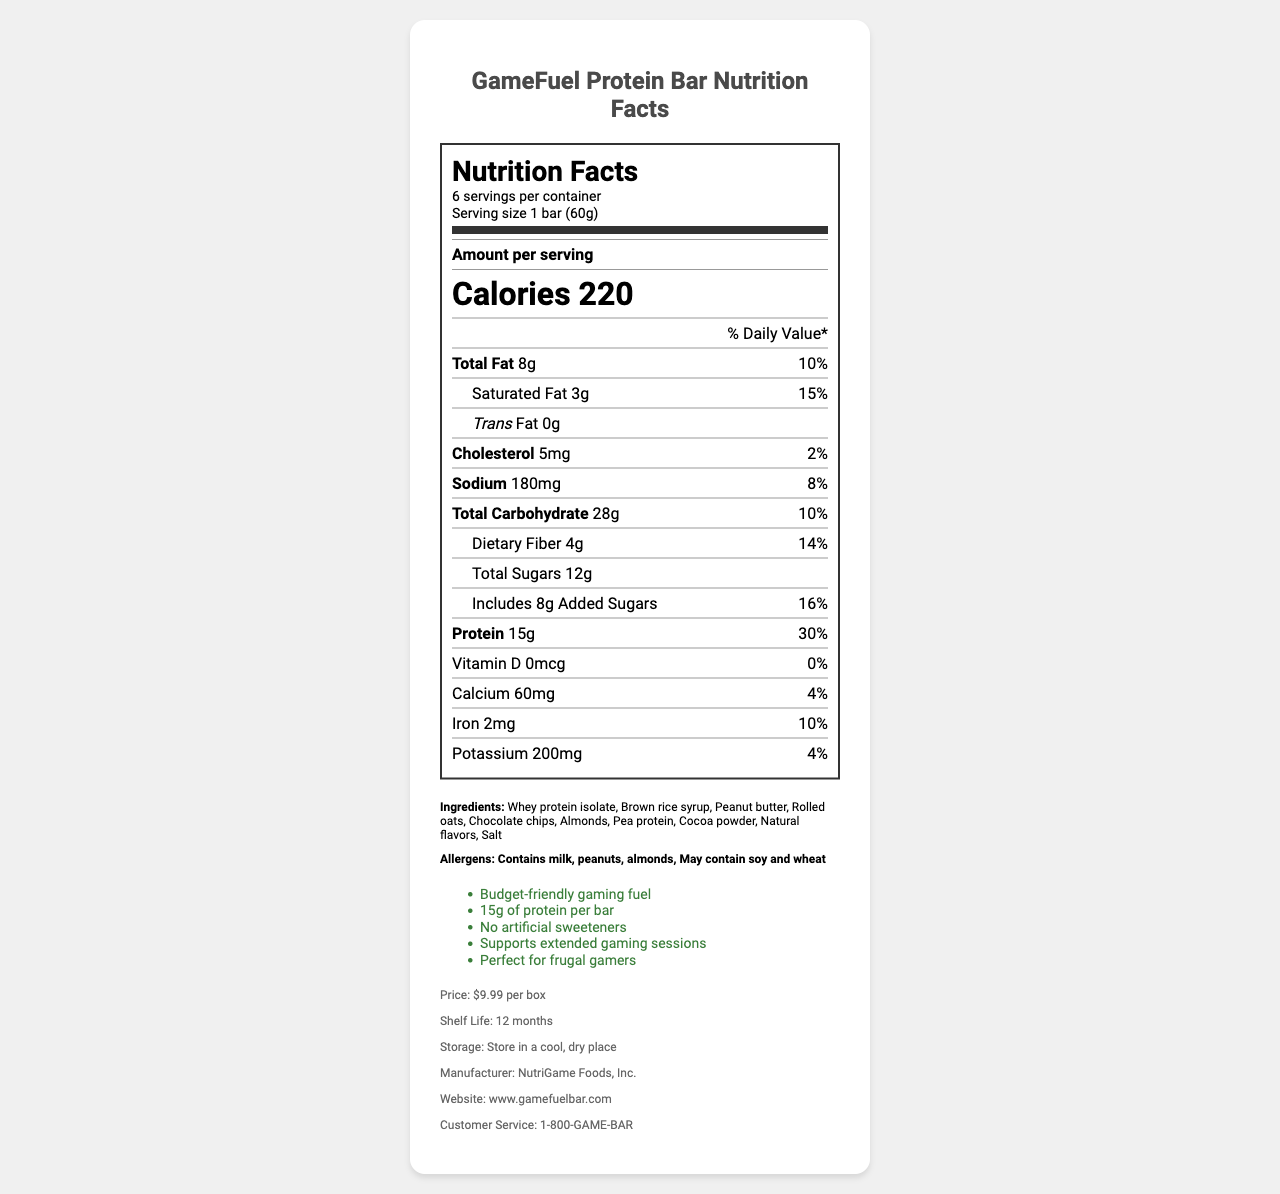which company manufactures the GameFuel Protein Bar? The manufacturer information is listed in the additional info section at the bottom of the document.
Answer: NutriGame Foods, Inc. what is the serving size of the GameFuel Protein Bar? The serving size is specified at the top of the nutrition label under the serving information.
Answer: 1 bar (60g) how many servings are there per container? The number of servings per container is listed in the serving information section at the top of the nutrition label.
Answer: 6 what is the total protein content per serving? The protein content is listed in the nutrient breakdown in the nutrition label.
Answer: 15g how many calories are there per serving? The calorie count per serving is prominently displayed in a larger font in the nutrients section of the label.
Answer: 220 which nutrient contributes the most to the daily value percentage? A. Total Fat B. Protein C. Cholesterol Protein has a daily value percentage of 30%, which is the highest listed in the document.
Answer: B. Protein how much added sugar is in each serving? The amount of added sugars per serving is detailed in the sub-nutrient section under carbohydrates.
Answer: 8g what is the daily value percentage of sodium? The daily value percentage of sodium is listed next to the sodium amount in the nutrition label.
Answer: 8% which ingredient is listed first in the GameFuel Protein Bar? The ingredients are ordered by weight, with the first one being the most prevalent, which is whey protein isolate in this case.
Answer: Whey protein isolate does the protein bar contain any dietary fiber? The nutrition label lists dietary fiber content as 4g per serving.
Answer: Yes which of the following allergens are present in the protein bar? A. Milk B. Tree Nuts C. Soy D. Seafood The allergen section lists "contains milk" and "contains almonds" (a tree nut). Soy is only a potential cross-contaminant, and seafood is not mentioned.
Answer: A. Milk B. Tree Nuts is the GameFuel Protein Bar suitable for someone with a peanut allergy? The allergen section mentions that the bar contains peanuts.
Answer: No what is the shelf life of the GameFuel Protein Bar? The shelf life information is listed in the additional info section at the bottom of the document.
Answer: 12 months how should the GameFuel Protein Bar be stored? The storage instructions are given in the additional info section of the document.
Answer: Store in a cool, dry place is this product promoted as having no artificial sweeteners? One of the marketing claims explicitly mentions "No artificial sweeteners".
Answer: Yes is the vitamin D content sufficient to meet 100% daily value? The vitamin D content is 0mcg, which is 0% of the daily value.
Answer: No summarize the main idea of the document. The document combines a detailed nutrition label with product-specific information such as ingredients, allergens, marketing claims, price, shelf life, storage instructions, manufacturer details, and customer service contact, aiming to inform potential buyers about the GameFuel Protein Bar's nutritional content and benefits.
Answer: The document provides detailed nutrition facts and additional product information for the GameFuel Protein Bar, marketed towards frugal gamers. It highlights the high protein content, allergen information, and marketing claims, emphasizing the product's affordability and suitability for extended gaming sessions. how many grams of cocoa powder are used in the product? The ingredients list does not provide specific quantities for each ingredient, so the exact amount of cocoa powder cannot be determined.
Answer: Not enough information 